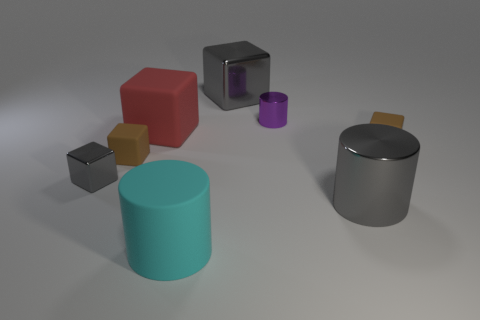What shape is the big red object?
Provide a succinct answer. Cube. Do the gray cylinder and the big cube right of the big cyan object have the same material?
Keep it short and to the point. Yes. What number of things are either cyan cylinders or gray cubes?
Your answer should be very brief. 3. Are there any tiny cyan things?
Offer a terse response. No. What shape is the large gray thing in front of the tiny metallic block that is to the left of the big cyan thing?
Keep it short and to the point. Cylinder. How many objects are either cyan cylinders that are in front of the gray metallic cylinder or rubber cubes on the right side of the big metal cylinder?
Offer a terse response. 2. What is the material of the red object that is the same size as the gray metallic cylinder?
Ensure brevity in your answer.  Rubber. The tiny shiny cube has what color?
Provide a short and direct response. Gray. The block that is both in front of the big gray metallic cube and on the right side of the red matte thing is made of what material?
Your answer should be very brief. Rubber. There is a big gray object behind the tiny metallic thing that is left of the tiny purple cylinder; are there any tiny purple metal cylinders left of it?
Your answer should be very brief. No. 